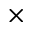<formula> <loc_0><loc_0><loc_500><loc_500>\times</formula> 